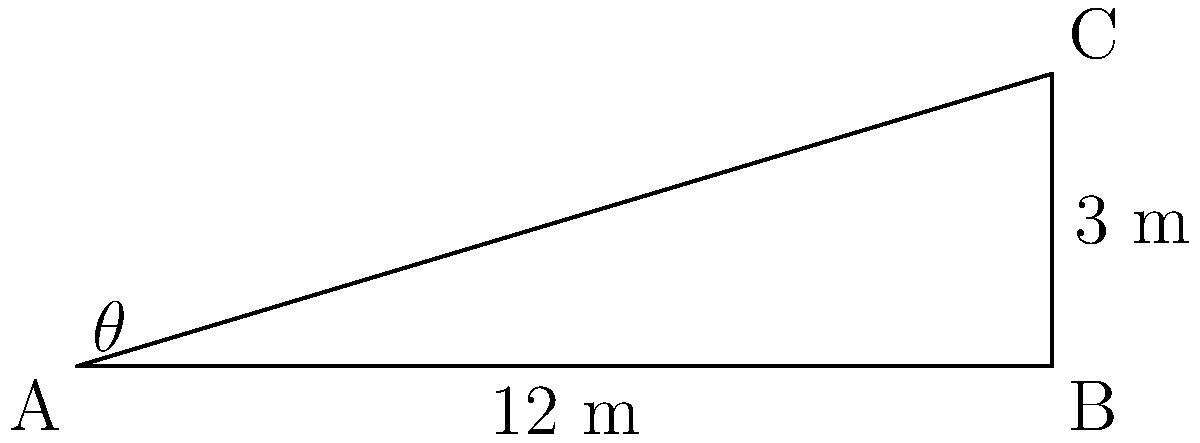During your latest excavation in Egypt, you've discovered a secret passage within a pyramid. The passage is 12 meters long and has a vertical drop of 3 meters. What is the angle of inclination ($\theta$) of this passage? Round your answer to the nearest degree. To find the angle of inclination, we can use trigonometry. Let's approach this step-by-step:

1) In the right triangle formed by the passage, we know:
   - The hypotenuse (length of the passage) = 12 m
   - The opposite side (vertical drop) = 3 m

2) We need to find the angle $\theta$. We can use the sine function:

   $$\sin(\theta) = \frac{\text{opposite}}{\text{hypotenuse}} = \frac{3}{12} = \frac{1}{4}$$

3) To find $\theta$, we need to take the inverse sine (arcsin):

   $$\theta = \arcsin(\frac{1}{4})$$

4) Using a calculator or trigonometric tables:

   $$\theta \approx 14.4775121...^\circ$$

5) Rounding to the nearest degree:

   $$\theta \approx 14^\circ$$

Therefore, the angle of inclination of the secret passage is approximately 14 degrees.
Answer: $14^\circ$ 